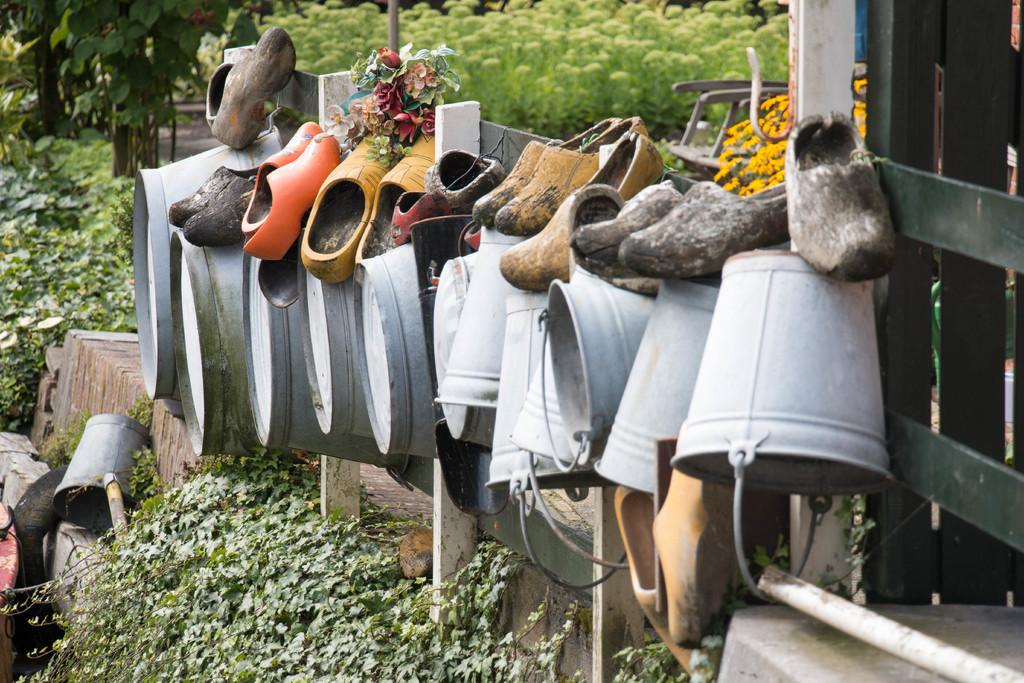What objects are located in the center of the image? There are buckets and shoes in the center of the image. What can be seen in the background of the image? There are trees, plants, and a chair in the background of the image. Are there any plants visible at the bottom of the image? Yes, there are plants at the bottom of the image. What grade did the team receive for their performance in the image? There is no team or performance mentioned in the image, so it's not possible to determine a grade. 